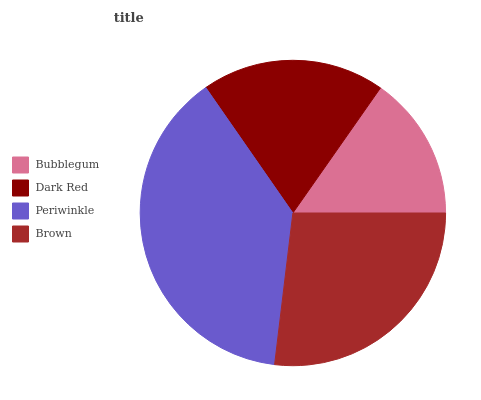Is Bubblegum the minimum?
Answer yes or no. Yes. Is Periwinkle the maximum?
Answer yes or no. Yes. Is Dark Red the minimum?
Answer yes or no. No. Is Dark Red the maximum?
Answer yes or no. No. Is Dark Red greater than Bubblegum?
Answer yes or no. Yes. Is Bubblegum less than Dark Red?
Answer yes or no. Yes. Is Bubblegum greater than Dark Red?
Answer yes or no. No. Is Dark Red less than Bubblegum?
Answer yes or no. No. Is Brown the high median?
Answer yes or no. Yes. Is Dark Red the low median?
Answer yes or no. Yes. Is Periwinkle the high median?
Answer yes or no. No. Is Bubblegum the low median?
Answer yes or no. No. 